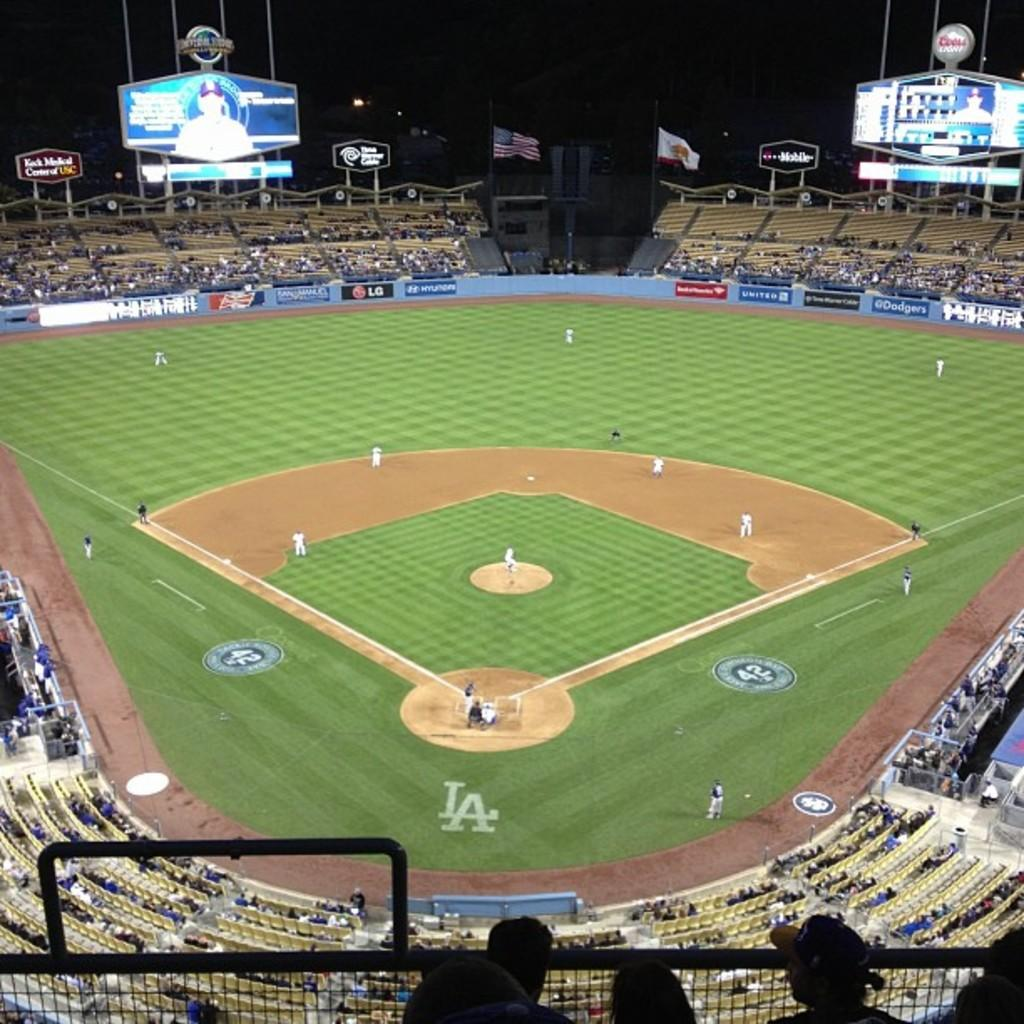<image>
Describe the image concisely. Baseball stadium with the Universal Studio logo on top of the scoreboard. 